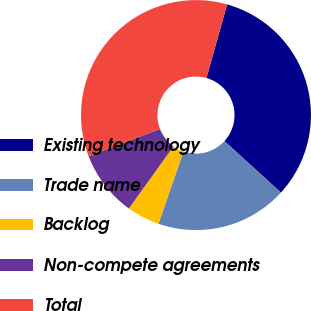<chart> <loc_0><loc_0><loc_500><loc_500><pie_chart><fcel>Existing technology<fcel>Trade name<fcel>Backlog<fcel>Non-compete agreements<fcel>Total<nl><fcel>32.41%<fcel>18.52%<fcel>4.63%<fcel>9.26%<fcel>35.19%<nl></chart> 